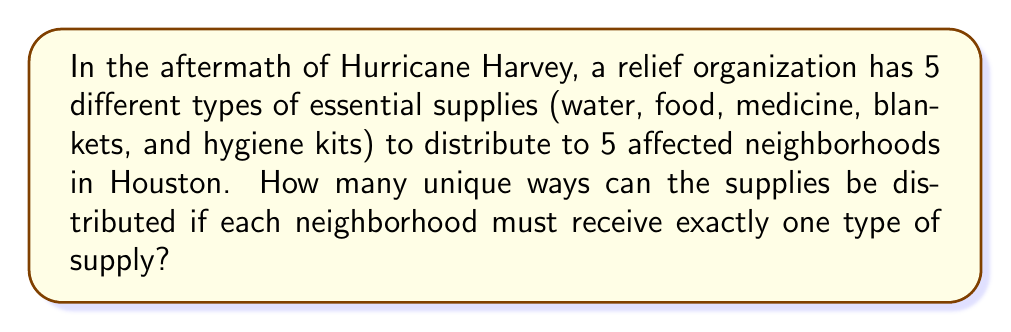Can you answer this question? To solve this problem, we need to use the concept of permutations from abstract algebra.

1) This scenario can be modeled as a permutation of 5 elements (the supplies) among 5 positions (the neighborhoods).

2) In abstract algebra, this is equivalent to finding the order of the symmetric group $S_5$.

3) The order of $S_n$ is given by $n!$, where $n$ is the number of elements being permuted.

4) In this case, $n = 5$, so we need to calculate $5!$.

5) $5! = 5 \times 4 \times 3 \times 2 \times 1 = 120$

Each permutation represents a unique way of distributing the supplies. For example:
- (water, food, medicine, blankets, hygiene kits) could represent one distribution.
- (food, water, blankets, hygiene kits, medicine) would represent a different distribution.

In terms of group theory, each of these distributions is an element of the symmetric group $S_5$, and the total number of elements in this group gives us the number of unique distributions.
Answer: $120$ unique ways 